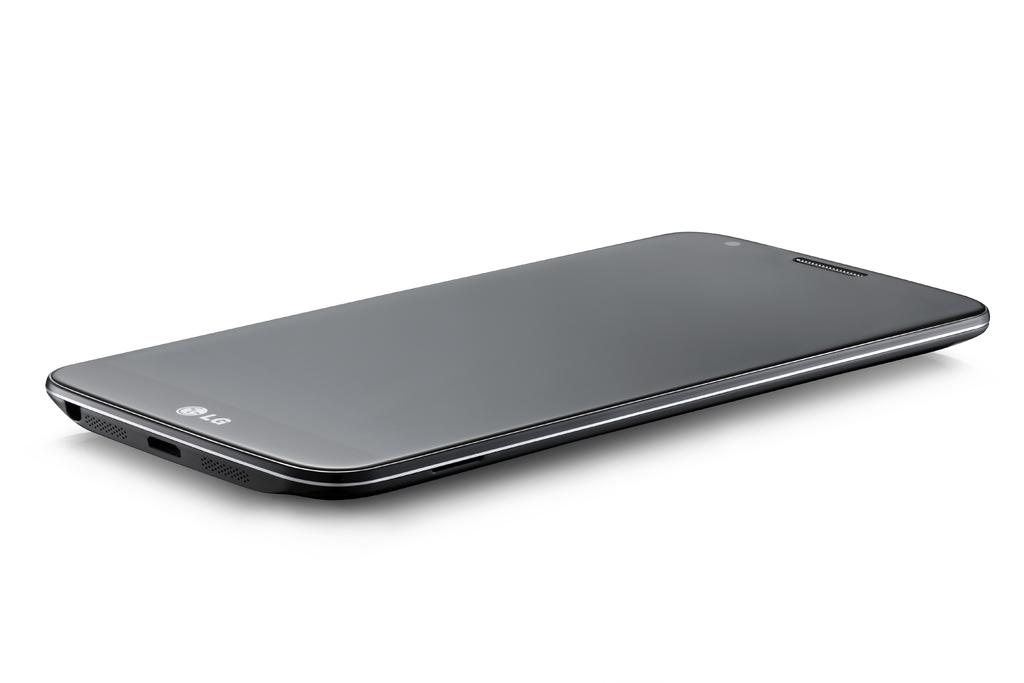<image>
Render a clear and concise summary of the photo. A black LG phone that is in good condition is surrounded by a white background. 